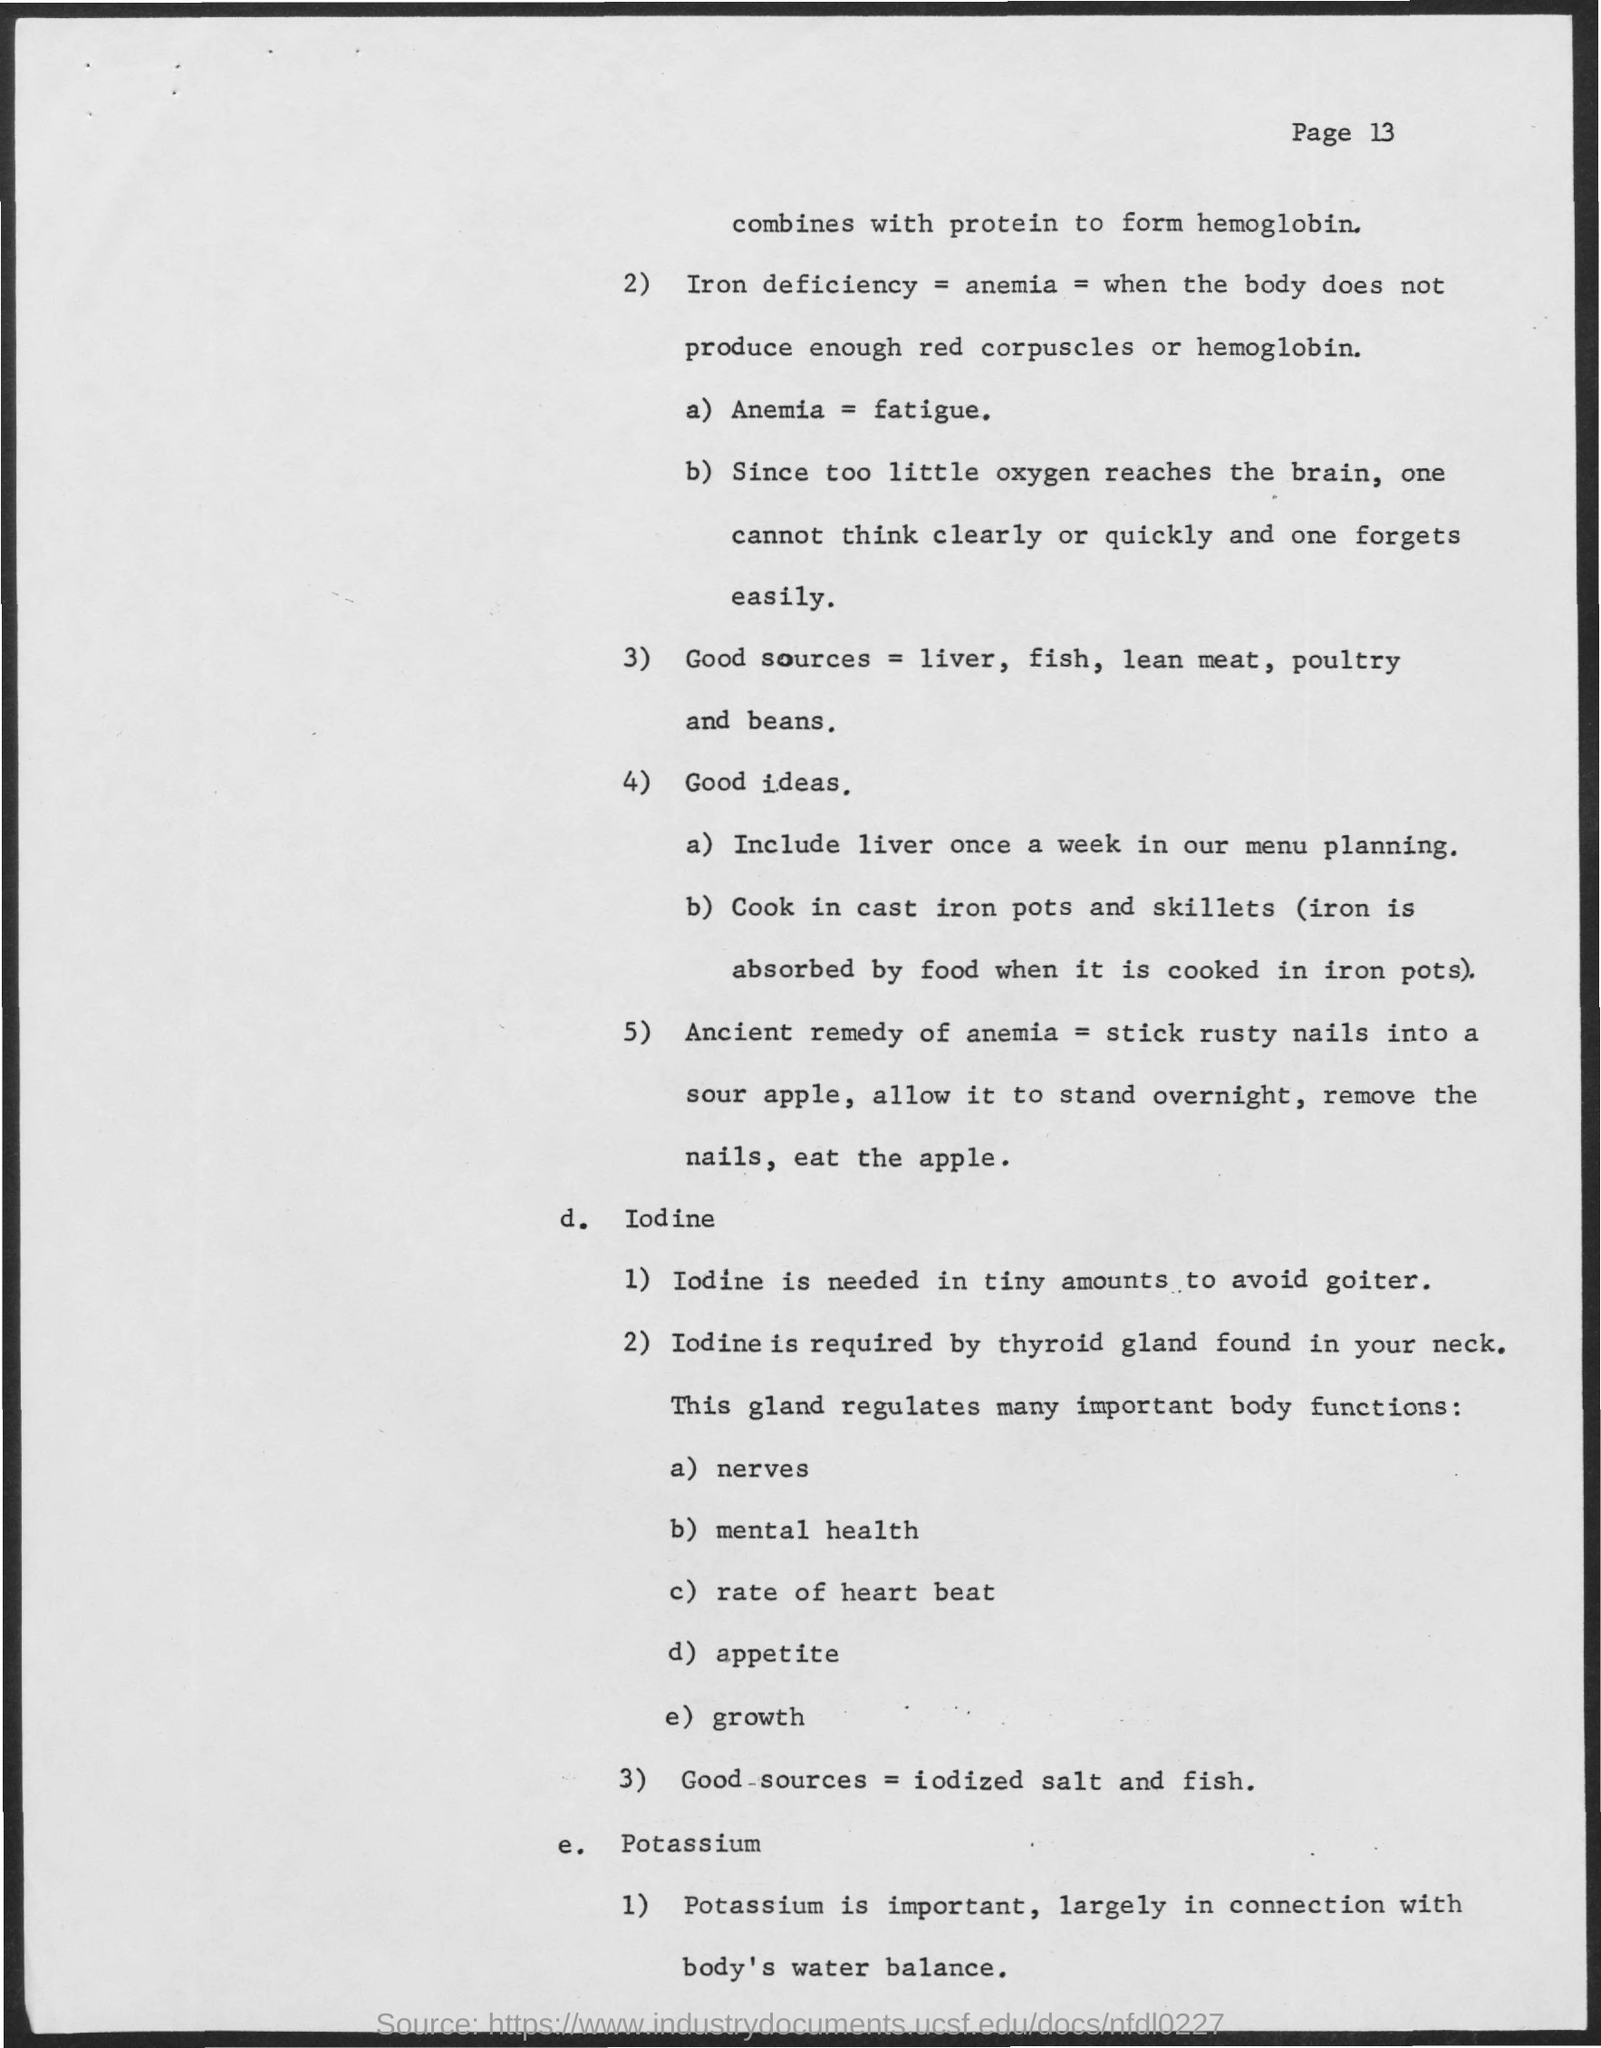Why one can not think clearly or quickly?
Give a very brief answer. Since too little oxygen reaches the brain. 